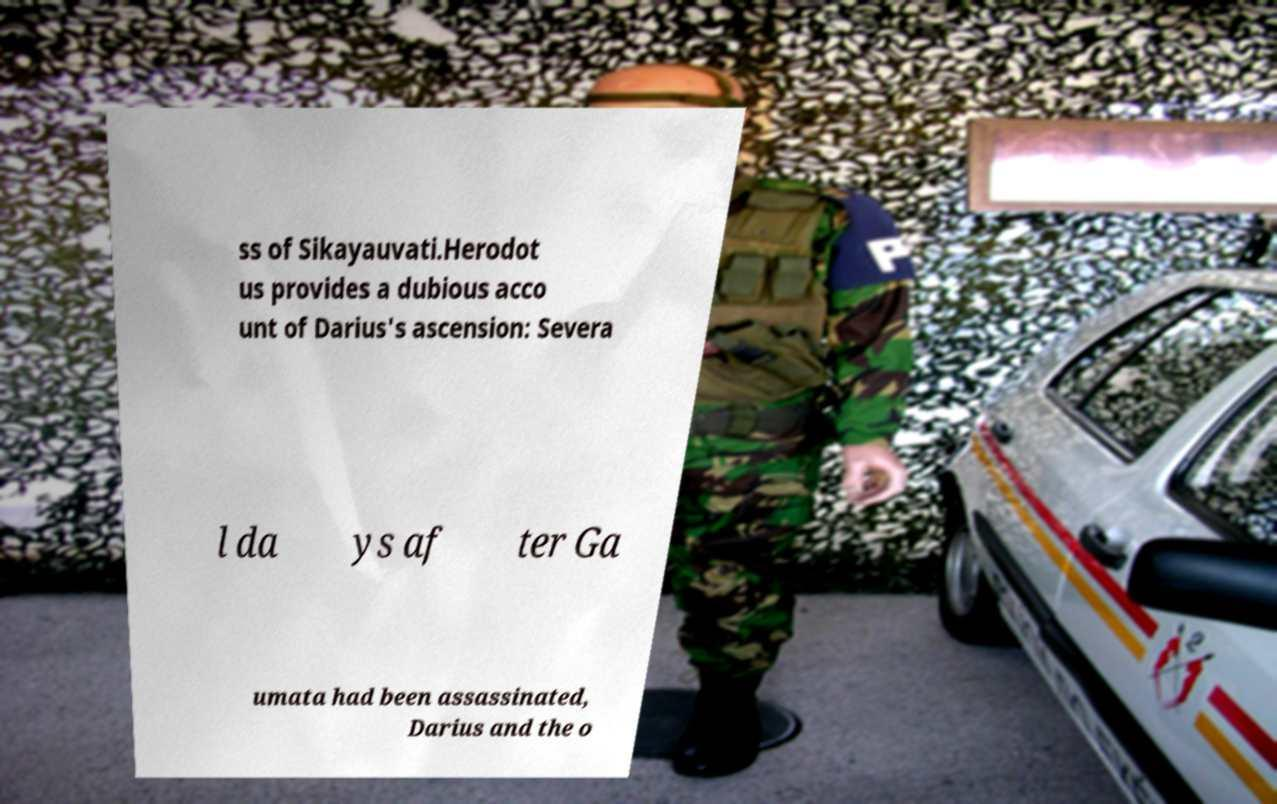For documentation purposes, I need the text within this image transcribed. Could you provide that? ss of Sikayauvati.Herodot us provides a dubious acco unt of Darius's ascension: Severa l da ys af ter Ga umata had been assassinated, Darius and the o 